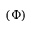Convert formula to latex. <formula><loc_0><loc_0><loc_500><loc_500>( \Phi )</formula> 